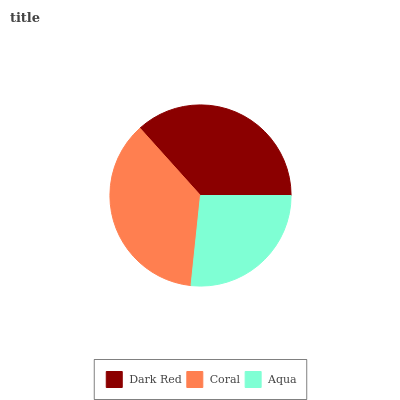Is Aqua the minimum?
Answer yes or no. Yes. Is Coral the maximum?
Answer yes or no. Yes. Is Coral the minimum?
Answer yes or no. No. Is Aqua the maximum?
Answer yes or no. No. Is Coral greater than Aqua?
Answer yes or no. Yes. Is Aqua less than Coral?
Answer yes or no. Yes. Is Aqua greater than Coral?
Answer yes or no. No. Is Coral less than Aqua?
Answer yes or no. No. Is Dark Red the high median?
Answer yes or no. Yes. Is Dark Red the low median?
Answer yes or no. Yes. Is Aqua the high median?
Answer yes or no. No. Is Coral the low median?
Answer yes or no. No. 